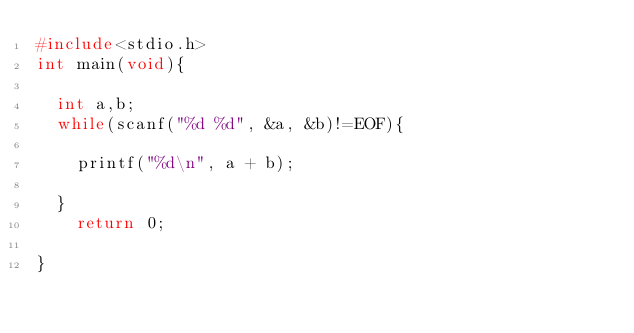Convert code to text. <code><loc_0><loc_0><loc_500><loc_500><_C_>#include<stdio.h>
int main(void){

  int a,b;
  while(scanf("%d %d", &a, &b)!=EOF){

    printf("%d\n", a + b);

  }
    return 0;
  
}</code> 